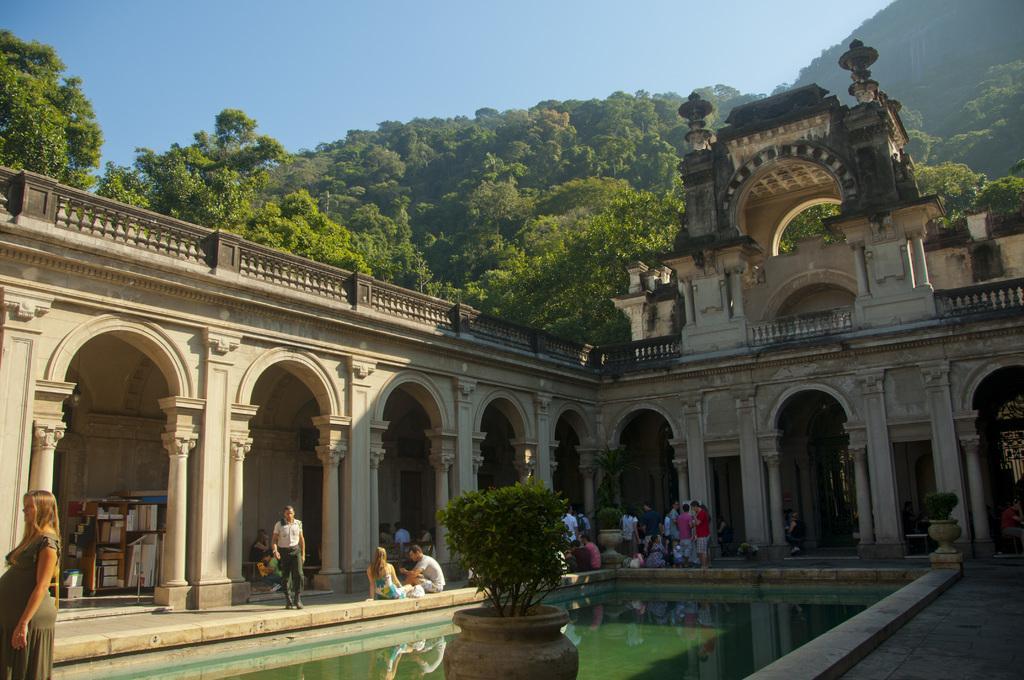How would you summarize this image in a sentence or two? In this image I can see few persons sitting and few other persons standing, a plant and water. In the background I can see the building, few trees, few mountains and the sky. 